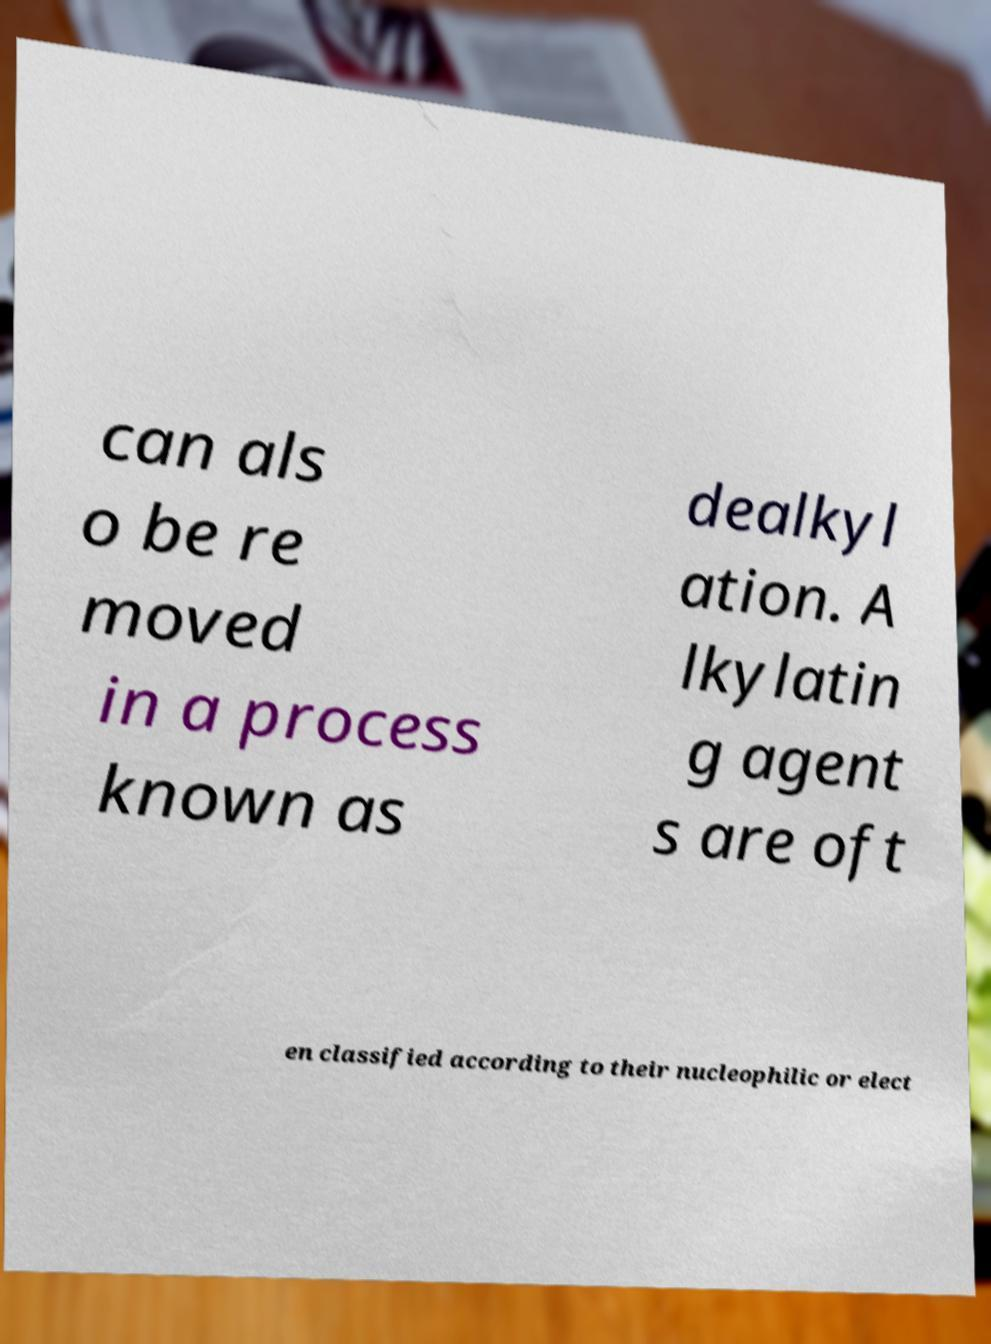Please read and relay the text visible in this image. What does it say? can als o be re moved in a process known as dealkyl ation. A lkylatin g agent s are oft en classified according to their nucleophilic or elect 